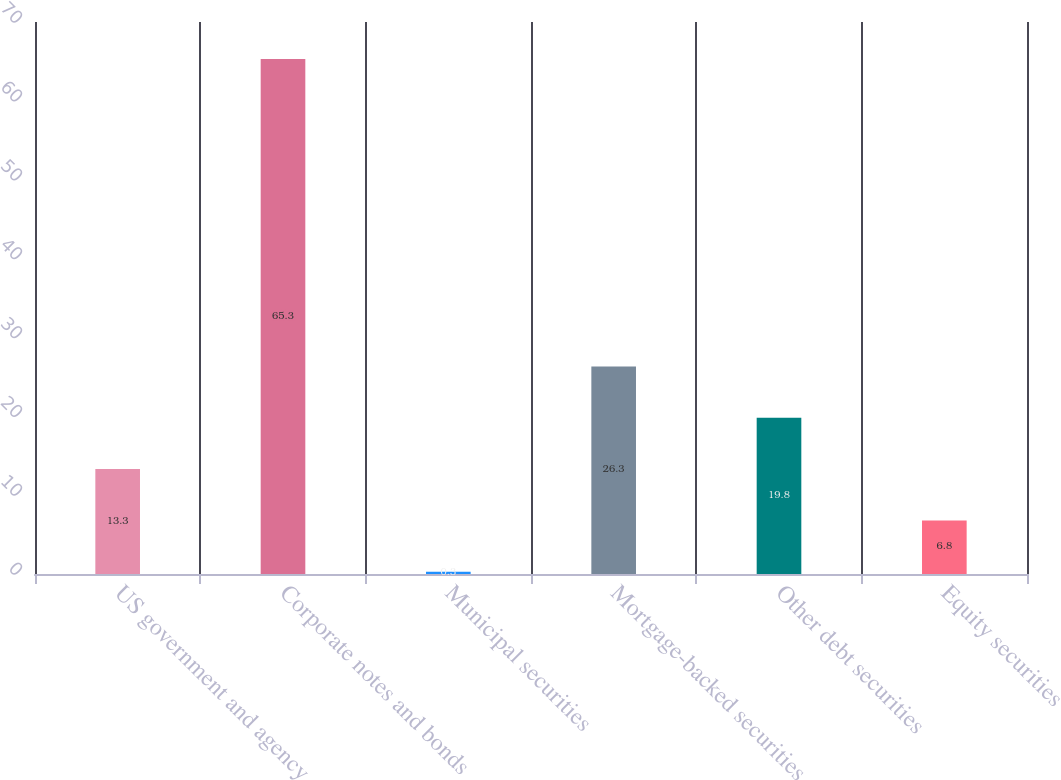Convert chart. <chart><loc_0><loc_0><loc_500><loc_500><bar_chart><fcel>US government and agency<fcel>Corporate notes and bonds<fcel>Municipal securities<fcel>Mortgage-backed securities<fcel>Other debt securities<fcel>Equity securities<nl><fcel>13.3<fcel>65.3<fcel>0.3<fcel>26.3<fcel>19.8<fcel>6.8<nl></chart> 